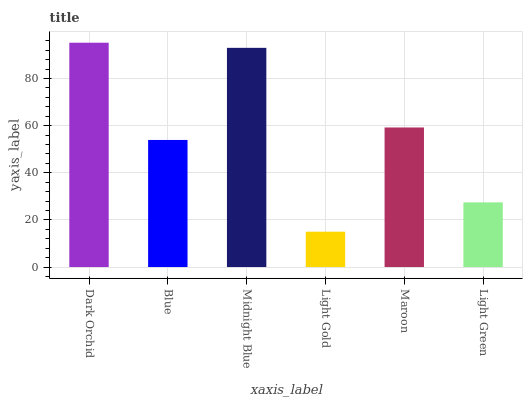Is Light Gold the minimum?
Answer yes or no. Yes. Is Dark Orchid the maximum?
Answer yes or no. Yes. Is Blue the minimum?
Answer yes or no. No. Is Blue the maximum?
Answer yes or no. No. Is Dark Orchid greater than Blue?
Answer yes or no. Yes. Is Blue less than Dark Orchid?
Answer yes or no. Yes. Is Blue greater than Dark Orchid?
Answer yes or no. No. Is Dark Orchid less than Blue?
Answer yes or no. No. Is Maroon the high median?
Answer yes or no. Yes. Is Blue the low median?
Answer yes or no. Yes. Is Midnight Blue the high median?
Answer yes or no. No. Is Dark Orchid the low median?
Answer yes or no. No. 